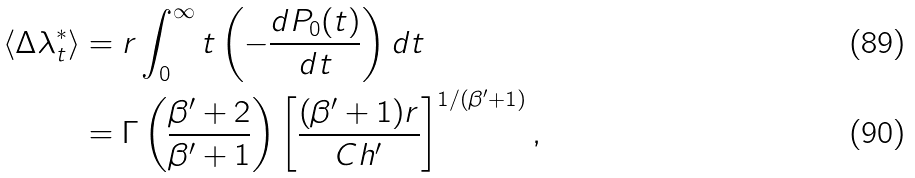<formula> <loc_0><loc_0><loc_500><loc_500>\langle \Delta \lambda ^ { * } _ { t } \rangle & = r \int _ { 0 } ^ { \infty } t \left ( - \frac { d P _ { 0 } ( t ) } { d t } \right ) d t \\ & = \Gamma \left ( \frac { \beta ^ { \prime } + 2 } { \beta ^ { \prime } + 1 } \right ) \left [ \frac { ( \beta ^ { \prime } + 1 ) r } { C h ^ { \prime } } \right ] ^ { 1 / ( \beta ^ { \prime } + 1 ) } ,</formula> 